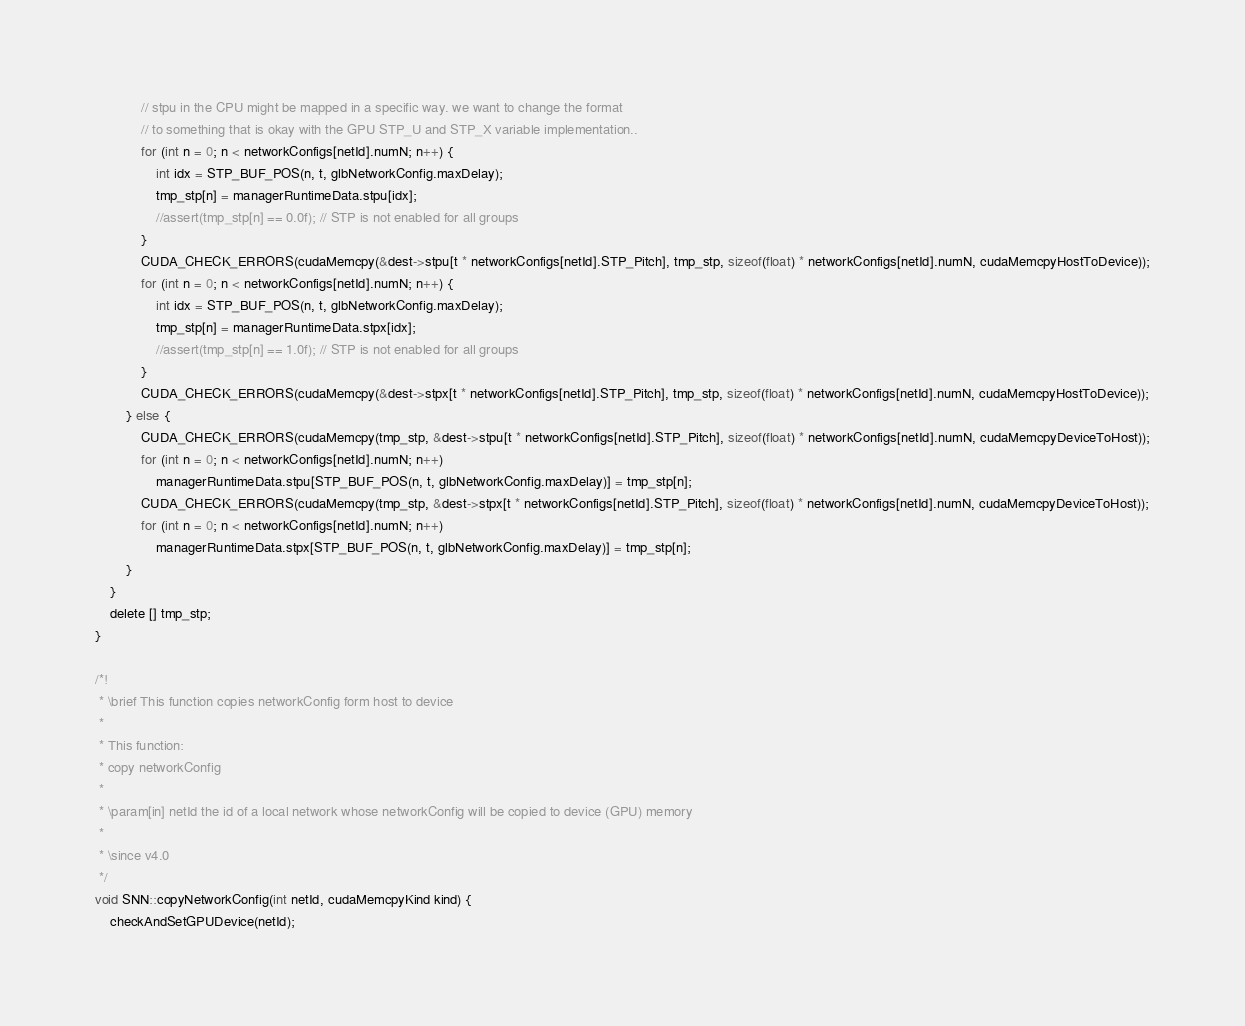Convert code to text. <code><loc_0><loc_0><loc_500><loc_500><_Cuda_>			// stpu in the CPU might be mapped in a specific way. we want to change the format
			// to something that is okay with the GPU STP_U and STP_X variable implementation..
			for (int n = 0; n < networkConfigs[netId].numN; n++) {
				int idx = STP_BUF_POS(n, t, glbNetworkConfig.maxDelay);
				tmp_stp[n] = managerRuntimeData.stpu[idx];
				//assert(tmp_stp[n] == 0.0f); // STP is not enabled for all groups
			}
			CUDA_CHECK_ERRORS(cudaMemcpy(&dest->stpu[t * networkConfigs[netId].STP_Pitch], tmp_stp, sizeof(float) * networkConfigs[netId].numN, cudaMemcpyHostToDevice));
			for (int n = 0; n < networkConfigs[netId].numN; n++) {
				int idx = STP_BUF_POS(n, t, glbNetworkConfig.maxDelay);
				tmp_stp[n] = managerRuntimeData.stpx[idx];
				//assert(tmp_stp[n] == 1.0f); // STP is not enabled for all groups
			}
			CUDA_CHECK_ERRORS(cudaMemcpy(&dest->stpx[t * networkConfigs[netId].STP_Pitch], tmp_stp, sizeof(float) * networkConfigs[netId].numN, cudaMemcpyHostToDevice));
		} else {
			CUDA_CHECK_ERRORS(cudaMemcpy(tmp_stp, &dest->stpu[t * networkConfigs[netId].STP_Pitch], sizeof(float) * networkConfigs[netId].numN, cudaMemcpyDeviceToHost));
			for (int n = 0; n < networkConfigs[netId].numN; n++)
				managerRuntimeData.stpu[STP_BUF_POS(n, t, glbNetworkConfig.maxDelay)] = tmp_stp[n];
			CUDA_CHECK_ERRORS(cudaMemcpy(tmp_stp, &dest->stpx[t * networkConfigs[netId].STP_Pitch], sizeof(float) * networkConfigs[netId].numN, cudaMemcpyDeviceToHost));
			for (int n = 0; n < networkConfigs[netId].numN; n++)
				managerRuntimeData.stpx[STP_BUF_POS(n, t, glbNetworkConfig.maxDelay)] = tmp_stp[n];
		}
	}
	delete [] tmp_stp;
}

/*!
 * \brief This function copies networkConfig form host to device
 *
 * This function:
 * copy networkConfig
 *
 * \param[in] netId the id of a local network whose networkConfig will be copied to device (GPU) memory
 *
 * \since v4.0
 */
void SNN::copyNetworkConfig(int netId, cudaMemcpyKind kind) {
	checkAndSetGPUDevice(netId);</code> 